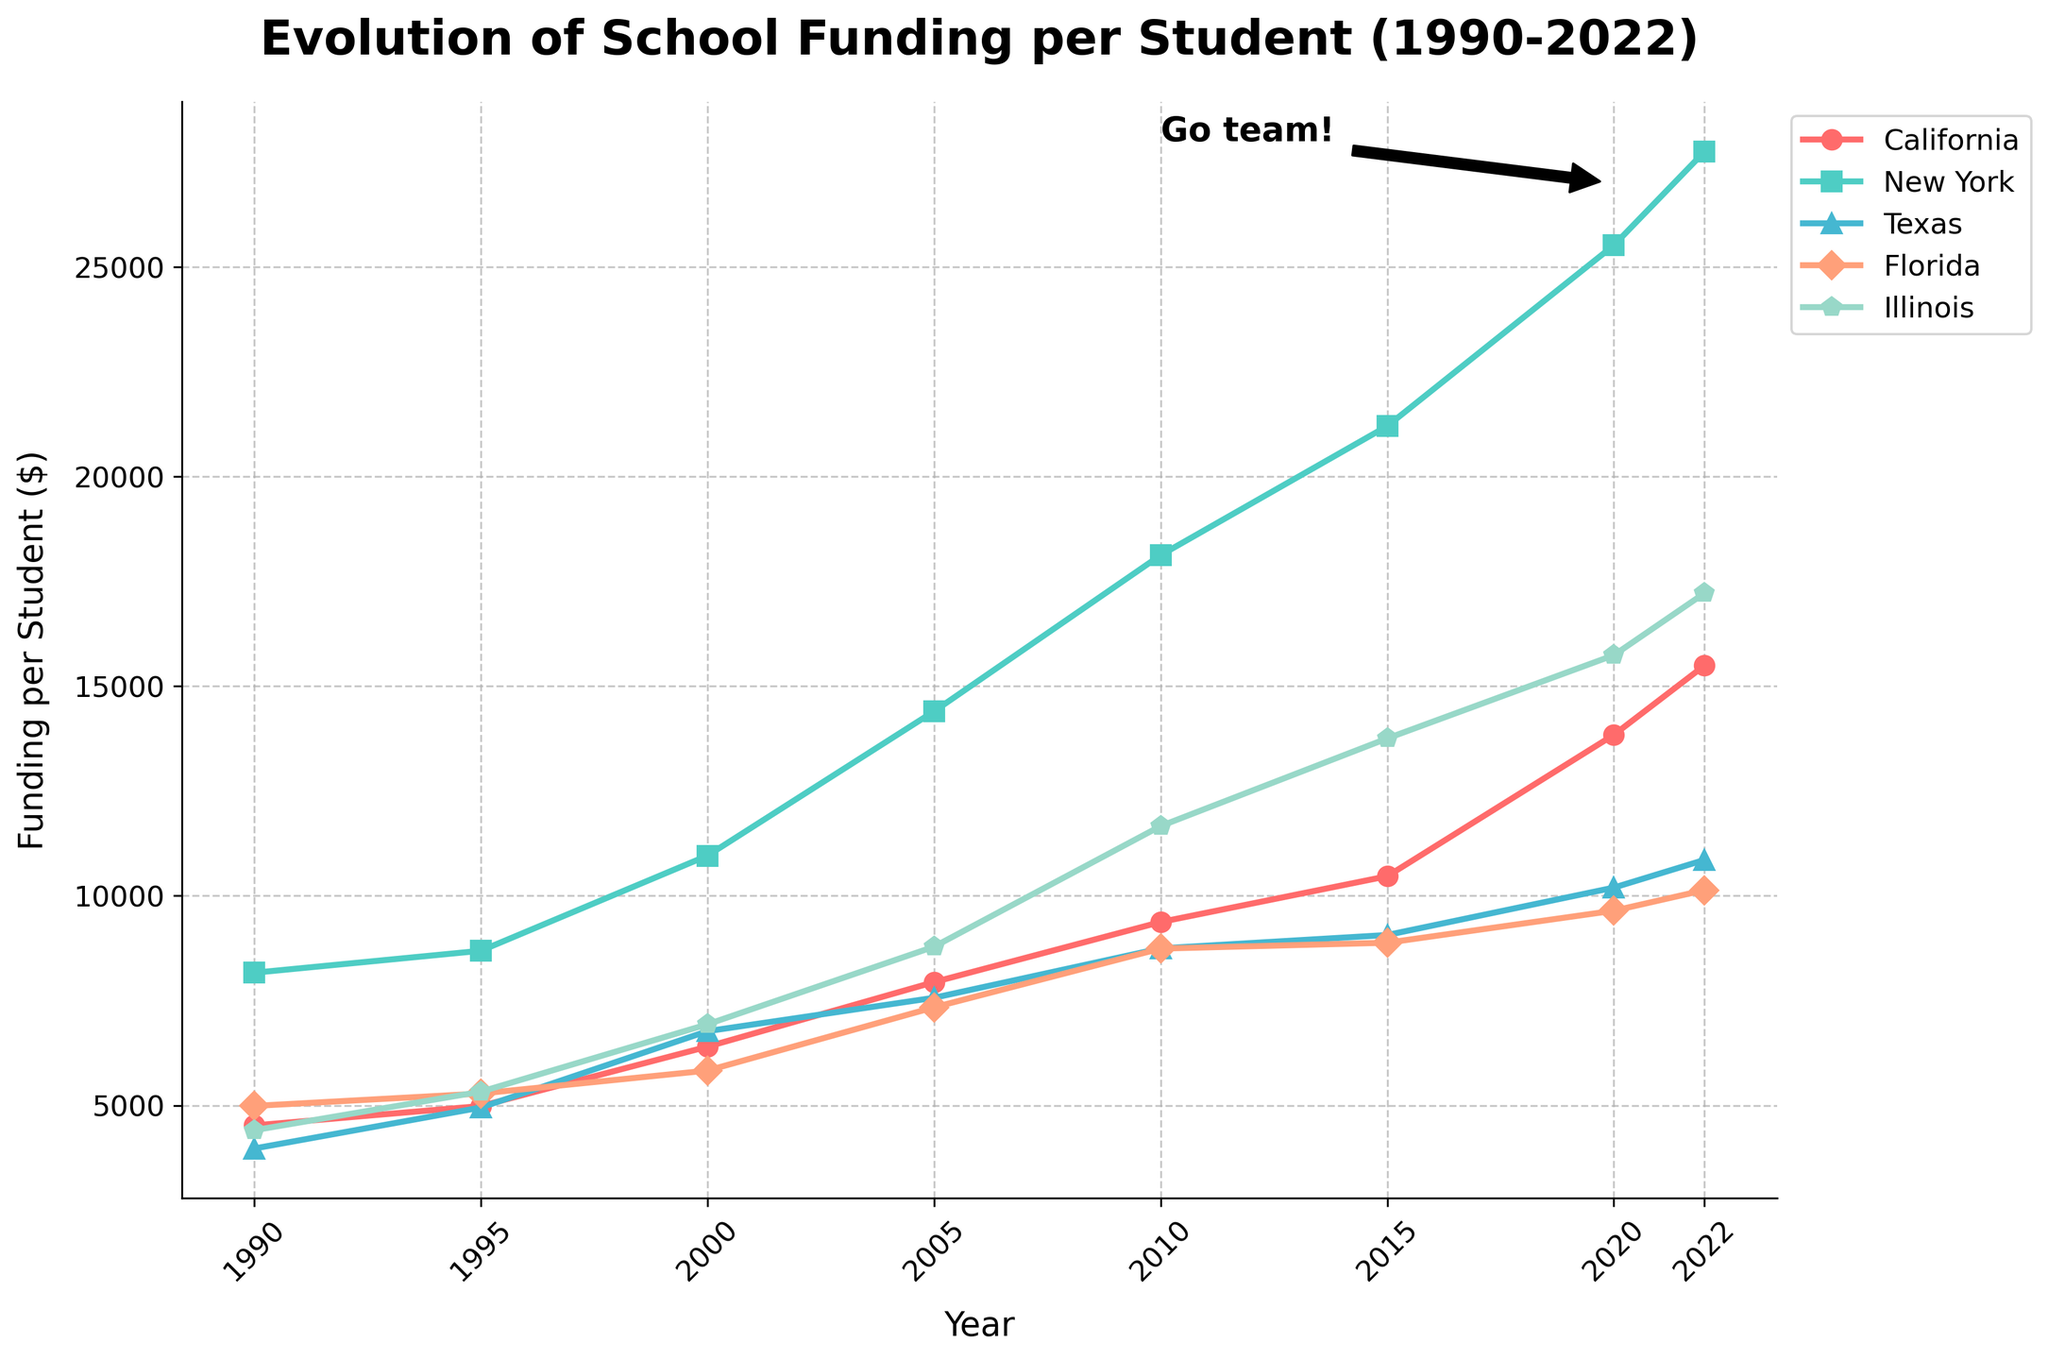What year did California's school funding per student surpass $10,000? We find the year when California's funding first exceeds $10,000 by examining the California line. It occurred in 2015 as depicted by the chart.
Answer: 2015 Which state had the least funding per student in 1990? By comparing the heights of the markers in 1990 for each state, Texas had the lowest value on the chart.
Answer: Texas What is the difference in school funding per student between New York and Florida in 2022? Locate 2022 for both New York and Florida on the x-axis, and compare their corresponding y-values, then subtract Florida's value from New York's value: 27755 - 10136 = 17619.
Answer: 17619 Which state saw the largest increase in school funding per student from 1990 to 2022? Calculate the difference for each state between 1990 and 2022, find the largest gain: 
- California: 15495 - 4523 = 10972 
- New York: 27755 - 8165 = 19590 
- Texas: 10857 - 3972 = 6885 
- Florida: 10136 - 4988 = 5148 
- Illinois: 17221 - 4408 = 12813
New York had the largest increase.
Answer: New York In which time period did Texas see the greatest increase in funding per student? Identify the largest interval change from the Texas line graph:
- 1990-1995: 4949 - 3972 = 977
- 1995-2000: 6771 - 4949 = 1822
- 2000-2005: 7567 - 6771 = 796
- 2005-2010: 8746 - 7567 = 1179
- 2010-2015: 9065 - 8746 = 319
- 2015-2020: 10196 - 9065 = 1131
- 2020-2022: 10857 - 10196 = 661
The largest increase was from 1995 to 2000.
Answer: 1995-2000 How does the funding per student in Illinois in 2005 compare to California in 2020? Read the values from the chart and directly compare them:
- Illinois (2005): 8786 
- California (2020): 13841 
California in 2020 had higher funding.
Answer: California in 2020 What's the average funding per student for Texas over the 30 years? Sum the values and divide by the number of years: 
(3972 + 4949 + 6771 + 7567 + 8746 + 9065 + 10196 + 10857) / 8 = 7265.875.
Answer: 7266 Which state has the steepest upward trend over the entire period? Visually compare the slopes of the lines for all states from 1990 to 2022. New York shows the steepest increase.
Answer: New York When did Florida's funding per student surpass $9,000 for the first time? Follow the Florida line and locate the year when it first exceeds $9,000. This occurs in 2020.
Answer: 2020 